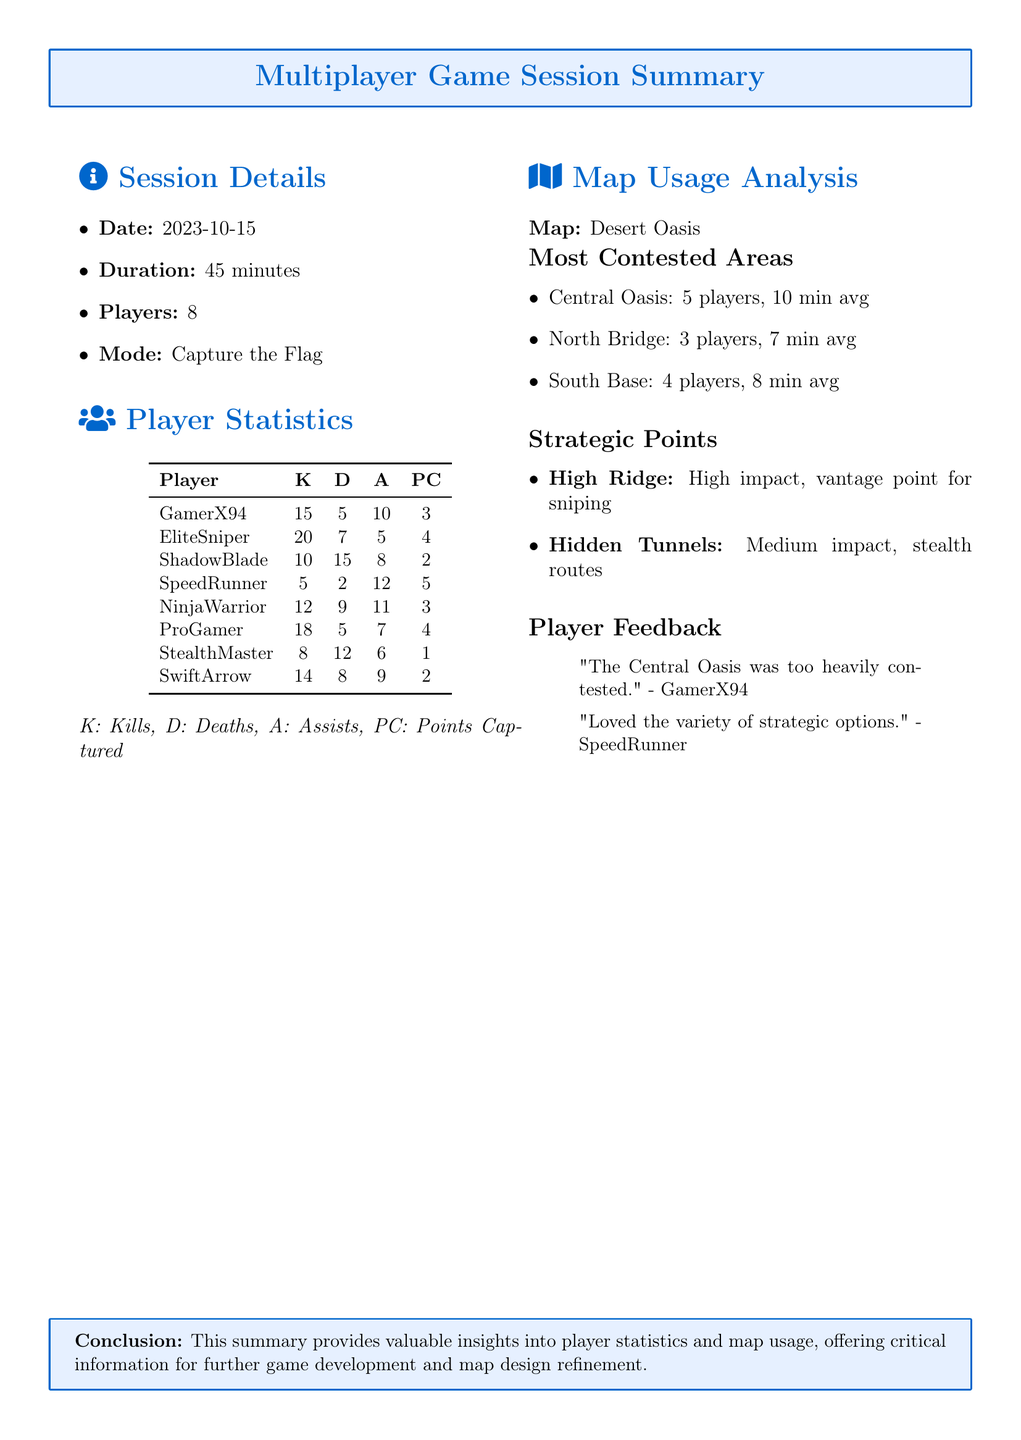What is the session date? The session date is specified in the summary as 2023-10-15.
Answer: 2023-10-15 How many players participated in the session? The document states that there were 8 players in the session.
Answer: 8 What is the duration of the game session? The duration of the session is mentioned as 45 minutes.
Answer: 45 minutes Which map was used during the gameplay? The map used for the session is indicated as Desert Oasis.
Answer: Desert Oasis Who had the highest number of kills? By reviewing the player statistics, EliteSniper is noted to have the highest kills at 20.
Answer: EliteSniper What is the average time spent in the Central Oasis? The average time players spent in the Central Oasis is detailed as 10 minutes.
Answer: 10 min Which strategic point is described as having high impact? The document identifies High Ridge as a high impact strategic point.
Answer: High Ridge What feedback did GamerX94 provide? GamerX94's feedback expressed that "The Central Oasis was too heavily contested."
Answer: "The Central Oasis was too heavily contested." How many assists did SpeedRunner achieve? The player statistics show that SpeedRunner had 12 assists.
Answer: 12 What game mode was played during the session? The game mode implemented for this session is noted as Capture the Flag.
Answer: Capture the Flag 